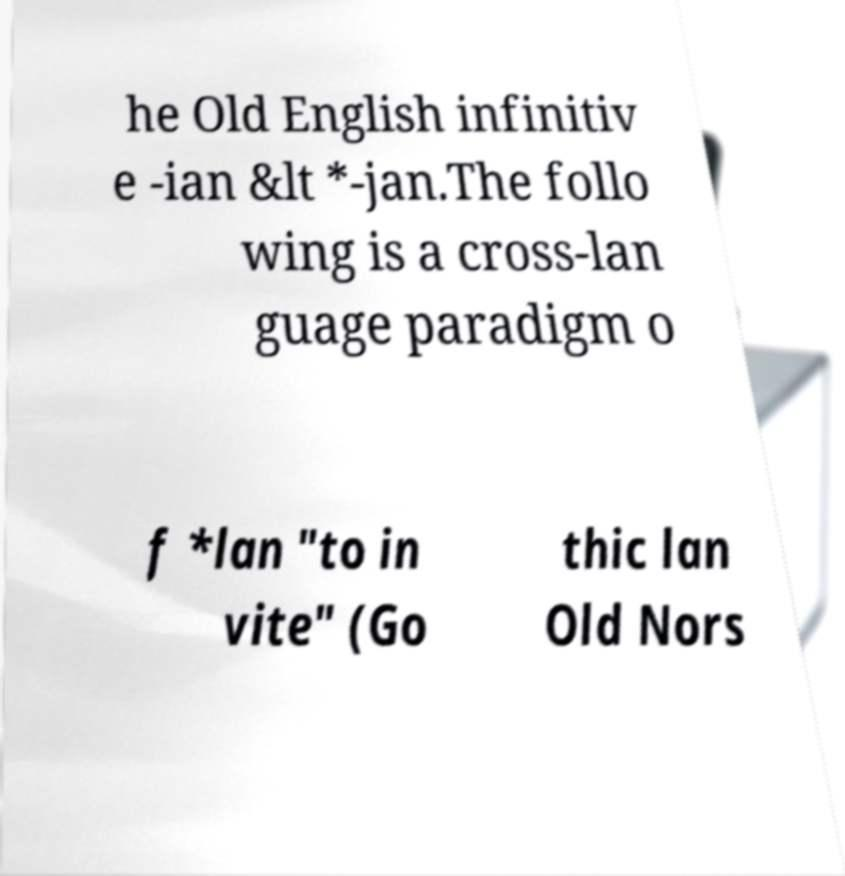Please read and relay the text visible in this image. What does it say? he Old English infinitiv e -ian &lt *-jan.The follo wing is a cross-lan guage paradigm o f *lan "to in vite" (Go thic lan Old Nors 